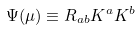<formula> <loc_0><loc_0><loc_500><loc_500>\Psi ( \mu ) \equiv R _ { a b } K ^ { a } K ^ { b }</formula> 